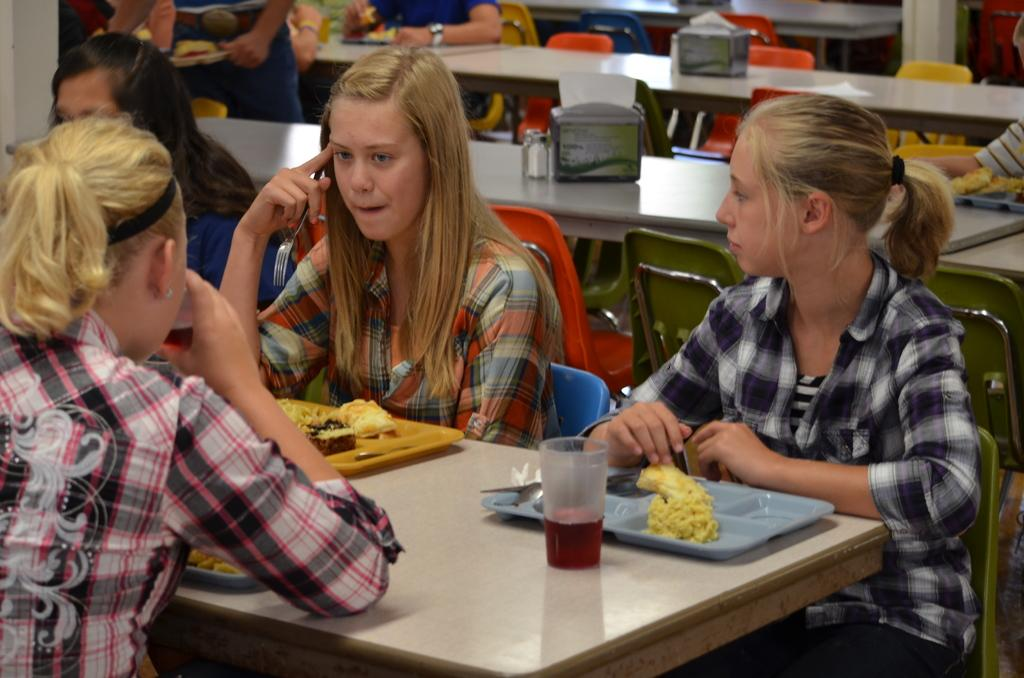What are the people in the image doing? The people in the image are sitting on chairs. What furniture is present in the image besides chairs? There are tables in the image. What can be seen on one of the tables? There is a glass on one of the tables. What else can be seen on the same table as the glass? There are plates on one of the tables. What type of bushes can be seen growing around the chairs in the image? There are no bushes present in the image; it only features people sitting on chairs, tables, a glass, and plates. 